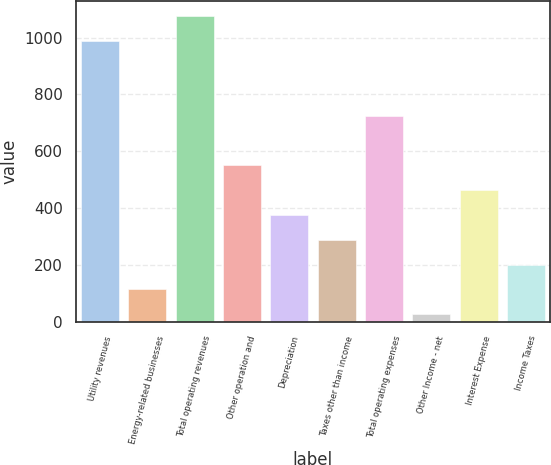Convert chart. <chart><loc_0><loc_0><loc_500><loc_500><bar_chart><fcel>Utility revenues<fcel>Energy-related businesses<fcel>Total operating revenues<fcel>Other operation and<fcel>Depreciation<fcel>Taxes other than income<fcel>Total operating expenses<fcel>Other Income - net<fcel>Interest Expense<fcel>Income Taxes<nl><fcel>987.4<fcel>113.4<fcel>1074.8<fcel>550.4<fcel>375.6<fcel>288.2<fcel>725.2<fcel>26<fcel>463<fcel>200.8<nl></chart> 